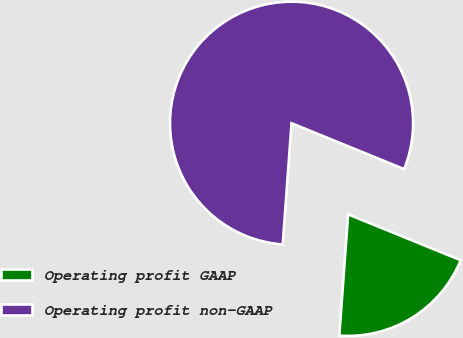Convert chart to OTSL. <chart><loc_0><loc_0><loc_500><loc_500><pie_chart><fcel>Operating profit GAAP<fcel>Operating profit non-GAAP<nl><fcel>20.0%<fcel>80.0%<nl></chart> 